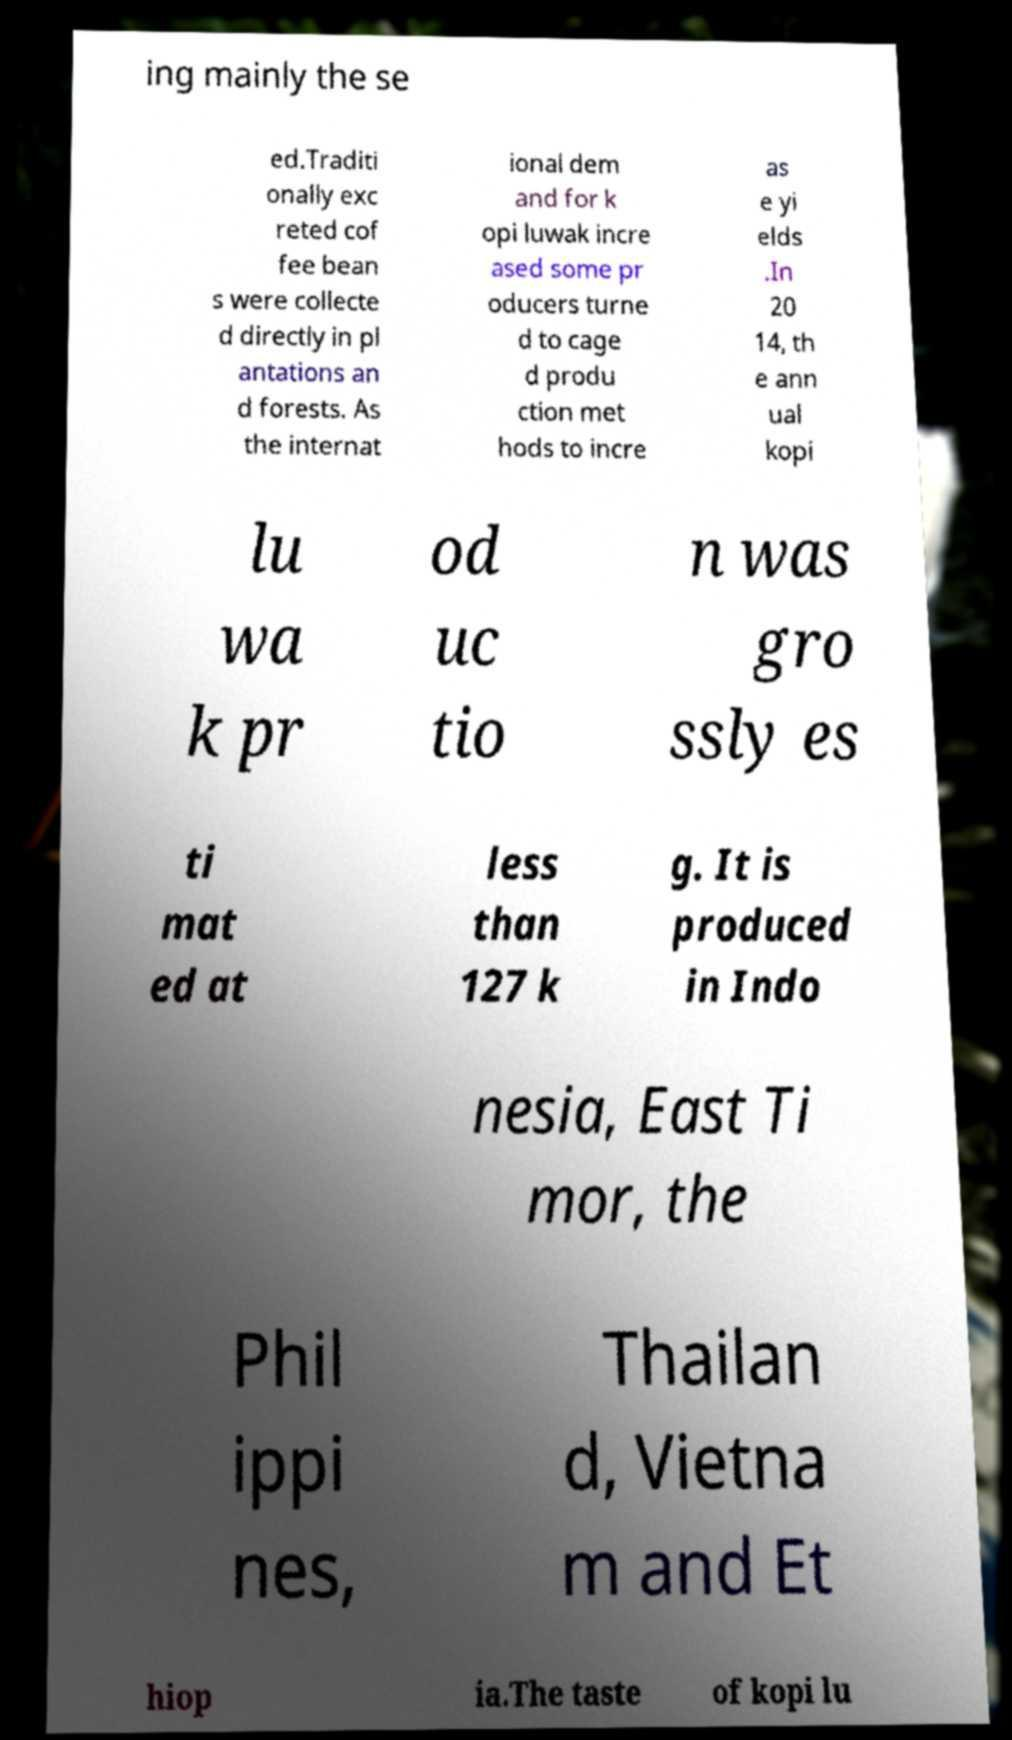Please read and relay the text visible in this image. What does it say? ing mainly the se ed.Traditi onally exc reted cof fee bean s were collecte d directly in pl antations an d forests. As the internat ional dem and for k opi luwak incre ased some pr oducers turne d to cage d produ ction met hods to incre as e yi elds .In 20 14, th e ann ual kopi lu wa k pr od uc tio n was gro ssly es ti mat ed at less than 127 k g. It is produced in Indo nesia, East Ti mor, the Phil ippi nes, Thailan d, Vietna m and Et hiop ia.The taste of kopi lu 